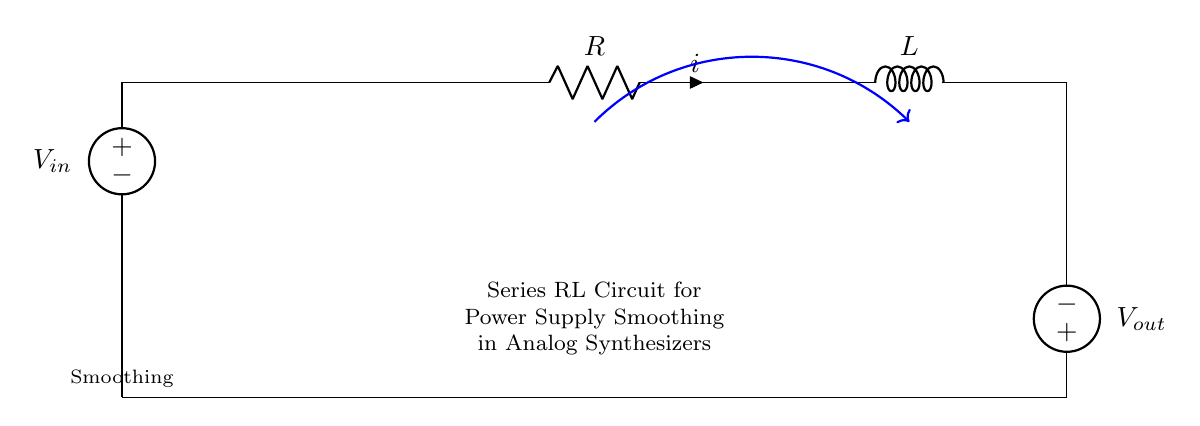What are the components in this circuit? The circuit contains a voltage source, a resistor, and an inductor. Each component is clearly labeled in the diagram, indicating their individual roles in the circuit.
Answer: voltage source, resistor, inductor What is the purpose of the resistor in this circuit? The resistor limits the current flow and affects the voltage drop across it, thereby influencing the overall behavior of the circuit. Its role is crucial in balancing the energy flow within the RL circuit.
Answer: limit current flow What voltage is present across the inductor? The diagram indicates that the inductor is connected directly after the resistor and before the output, and since it is part of the series configuration, the voltage across it would be the difference between the input voltage and the voltage across the resistor.
Answer: Vout = Vin - (R * i) What is the current direction in this circuit? The current flows from the positive terminal of the voltage source, through the resistor and inductor, and then returns to the negative terminal of the voltage source. This is a fundamental characteristic of series circuits, where the current remains the same throughout all components.
Answer: clockwise How does the inductor contribute to power supply smoothing? The inductor stores energy in a magnetic field when current flows through it, and when sudden changes occur, it releases this energy, thus helping to smooth out variations in voltage in the supply. This action minimizes voltage fluctuations, which is particularly beneficial for sensitive analog components like synthesizers.
Answer: stores and releases energy What happens to the voltage if the resistance is increased? If the resistance increases, the current flowing through the circuit will decrease, leading to a lower voltage drop across the inductor, which alters the output voltage. The change in resistance directly affects current levels and the inductor's behavior, impacting overall circuit performance.
Answer: increases output voltage What is the layout configuration of the circuit? The layout of this circuit is series configuration, as all components (voltage source, resistor, inductor) are connected end-to-end, meaning that they share the same current and voltage drop across each component adds up to the total voltage supplied.
Answer: series configuration 